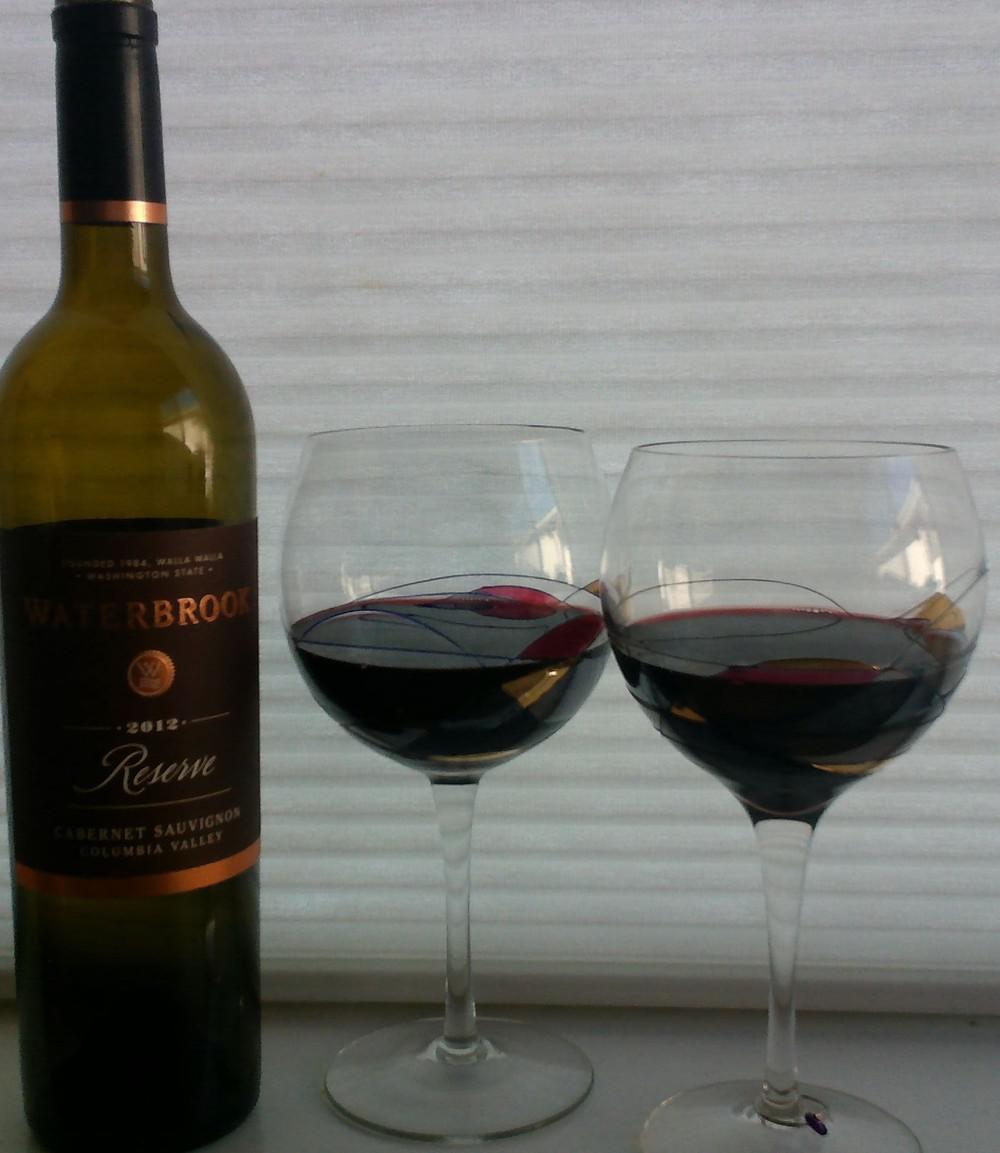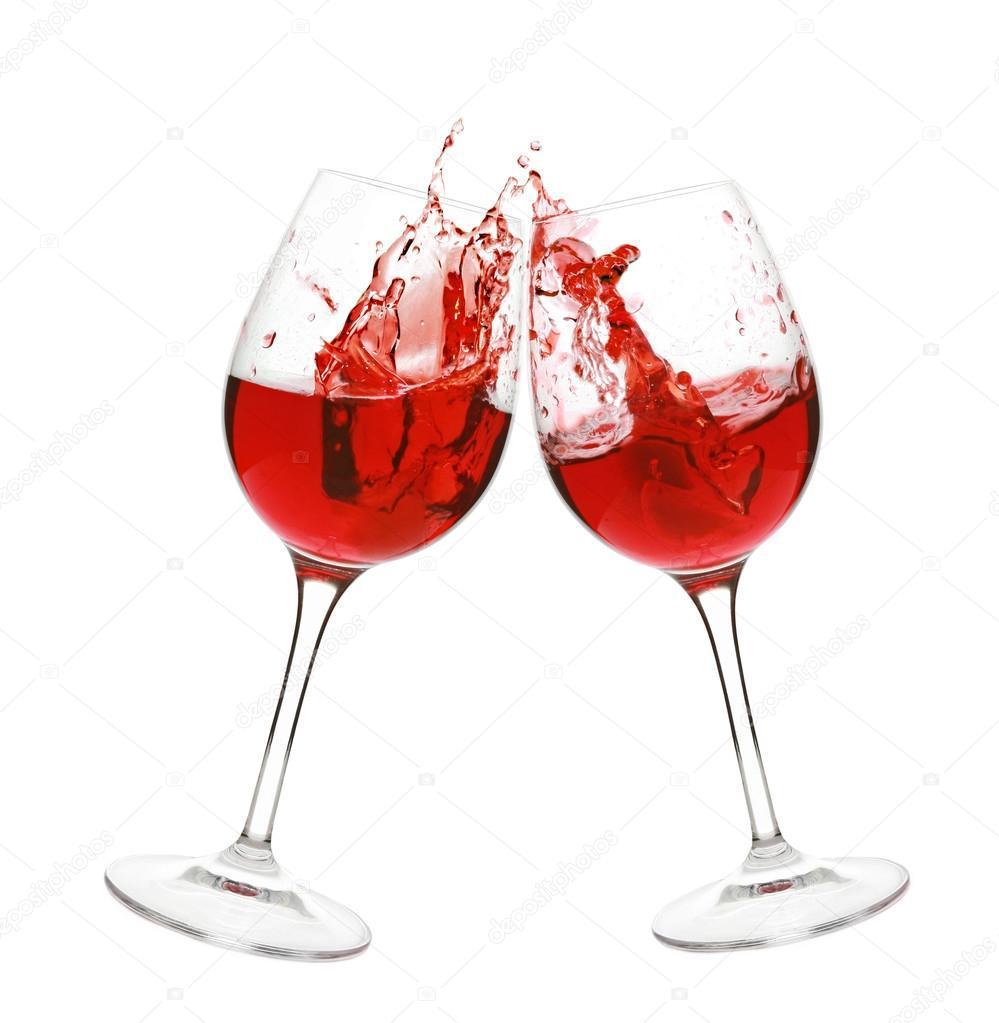The first image is the image on the left, the second image is the image on the right. Evaluate the accuracy of this statement regarding the images: "Each image contains two wine glasses and no bottles, and left image shows red wine splashing from glasses clinked together.". Is it true? Answer yes or no. No. 